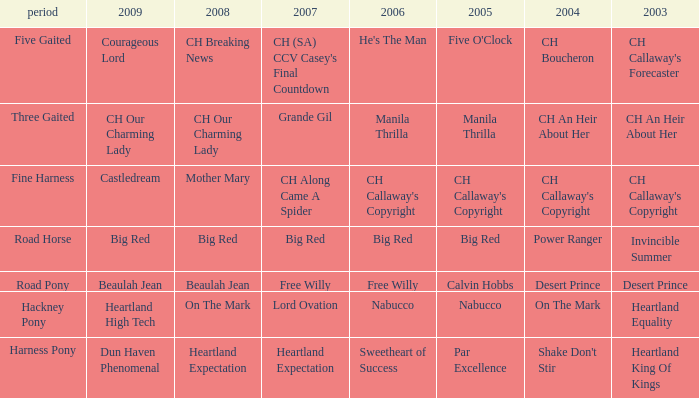What year is the 2004 shake don't stir? Harness Pony. 